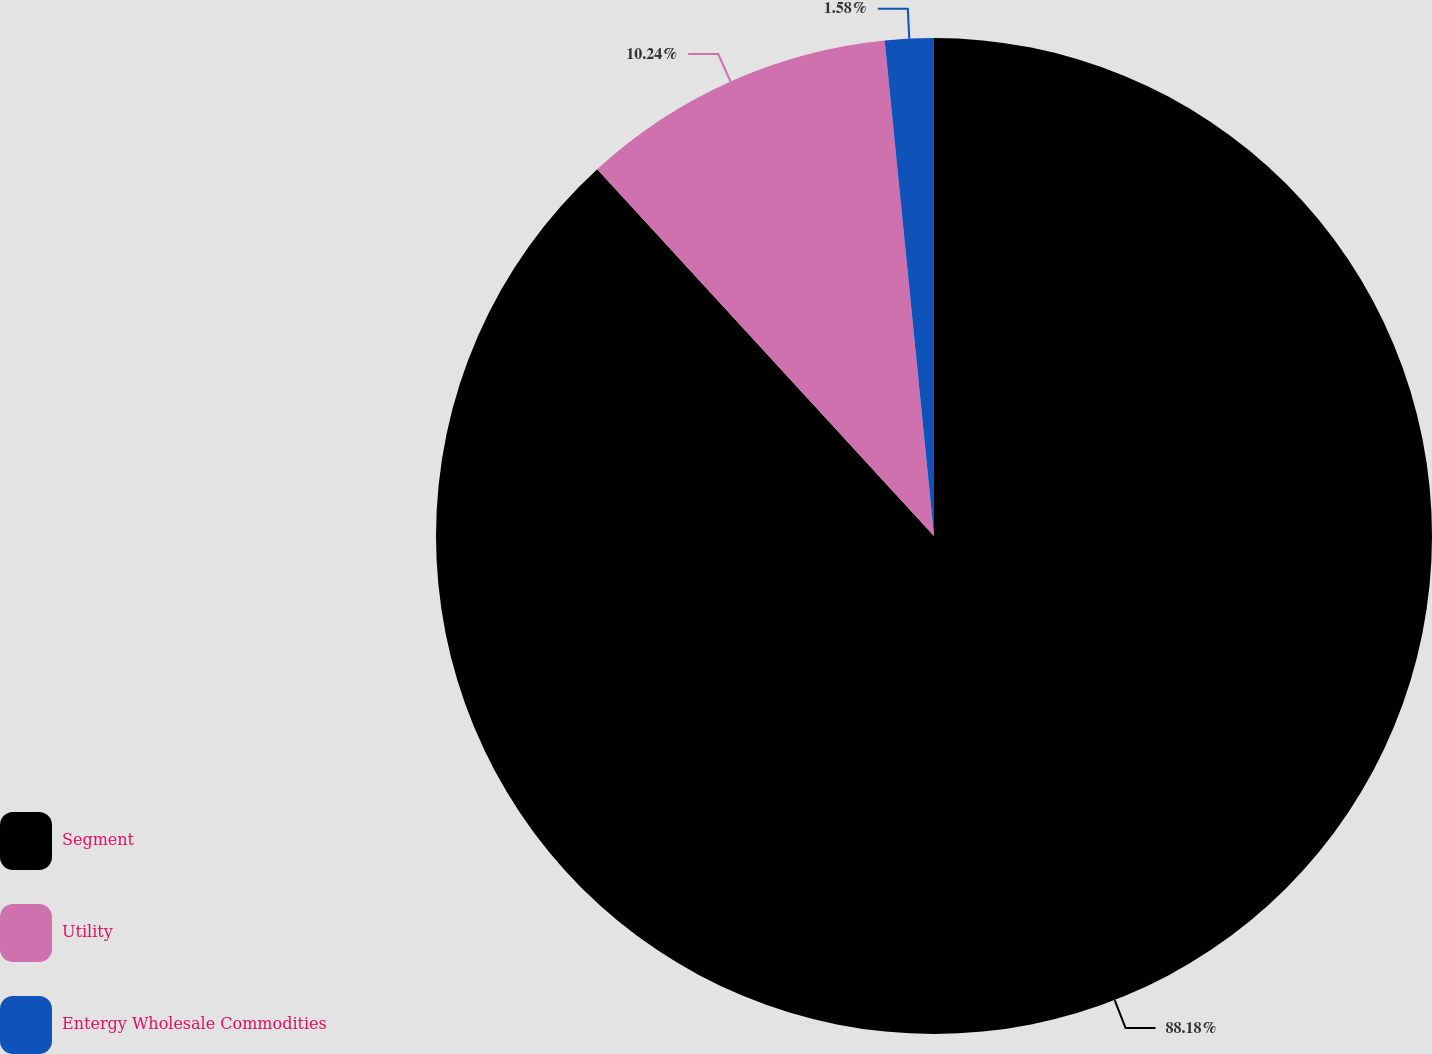Convert chart. <chart><loc_0><loc_0><loc_500><loc_500><pie_chart><fcel>Segment<fcel>Utility<fcel>Entergy Wholesale Commodities<nl><fcel>88.18%<fcel>10.24%<fcel>1.58%<nl></chart> 